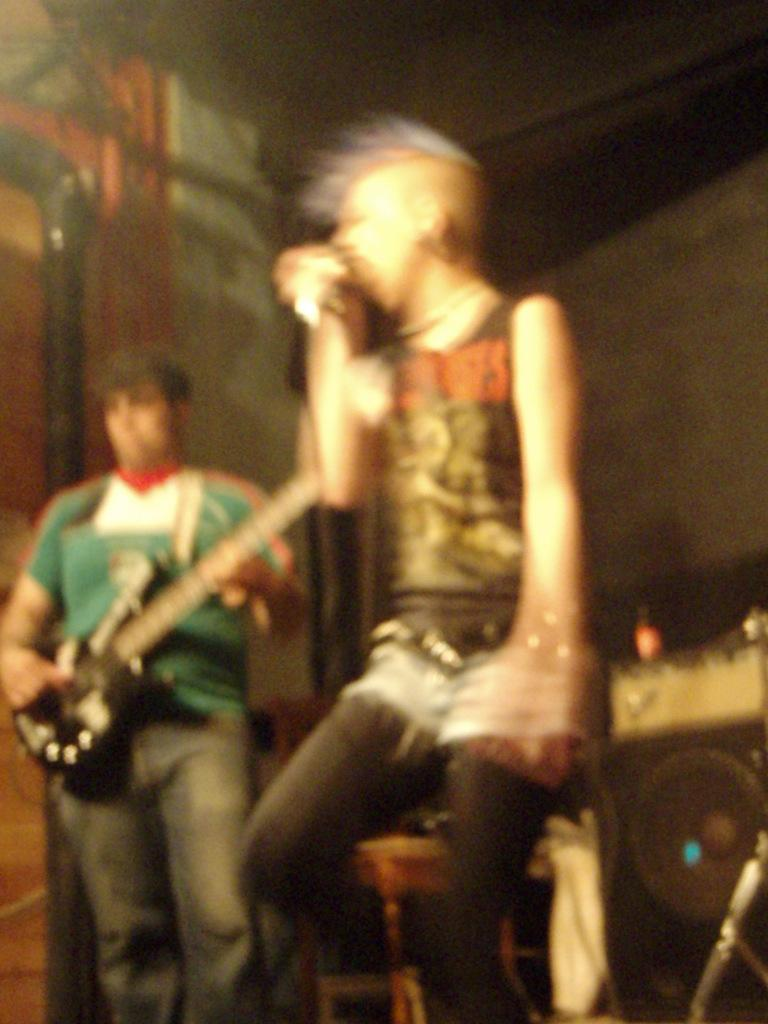How many people are in the image? There are two people in the image. What is one of the people holding? One of the people is holding a guitar. What type of pipe is being played during the feast in the image? There is no pipe or feast present in the image; it features two people, one of whom is holding a guitar. 